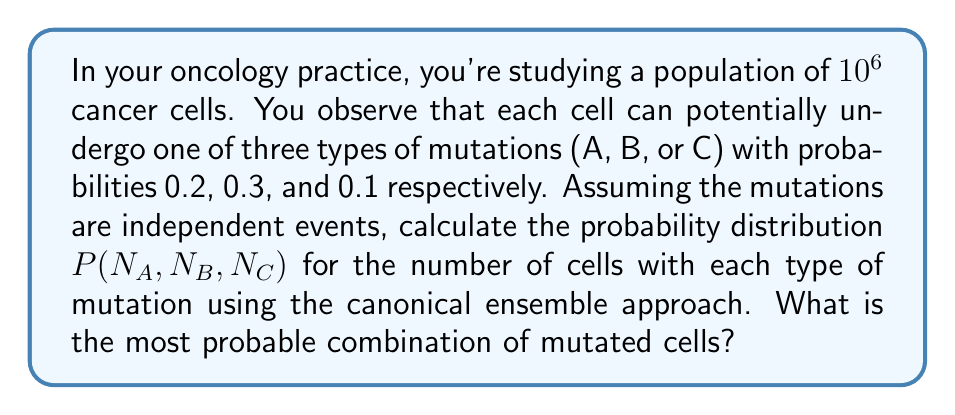Give your solution to this math problem. To solve this problem, we'll use the principles of statistical mechanics and the canonical ensemble approach:

1. Define the system: We have a total of N = 10^6 cancer cells, each with the possibility of undergoing mutations A, B, or C.

2. Probabilities: 
   P(A) = 0.2, P(B) = 0.3, P(C) = 0.1
   P(no mutation) = 1 - (0.2 + 0.3 + 0.1) = 0.4

3. The probability distribution for this system follows a multinomial distribution:

   $$P(N_A, N_B, N_C) = \frac{N!}{N_A! N_B! N_C! (N-N_A-N_B-N_C)!} \cdot (0.2)^{N_A} \cdot (0.3)^{N_B} \cdot (0.1)^{N_C} \cdot (0.4)^{N-N_A-N_B-N_C}$$

4. To find the most probable combination, we need to maximize this probability. In the limit of large N, this is equivalent to minimizing the free energy of the system.

5. The expected values for each mutation type are:
   $\langle N_A \rangle = N \cdot P(A) = 10^6 \cdot 0.2 = 2 \times 10^5$
   $\langle N_B \rangle = N \cdot P(B) = 10^6 \cdot 0.3 = 3 \times 10^5$
   $\langle N_C \rangle = N \cdot P(C) = 10^6 \cdot 0.1 = 1 \times 10^5$

6. These expected values represent the most probable combination of mutated cells.
Answer: P(N_A, N_B, N_C) = Multinomial(10^6, [0.2, 0.3, 0.1, 0.4]); Most probable: N_A = 2×10^5, N_B = 3×10^5, N_C = 1×10^5 